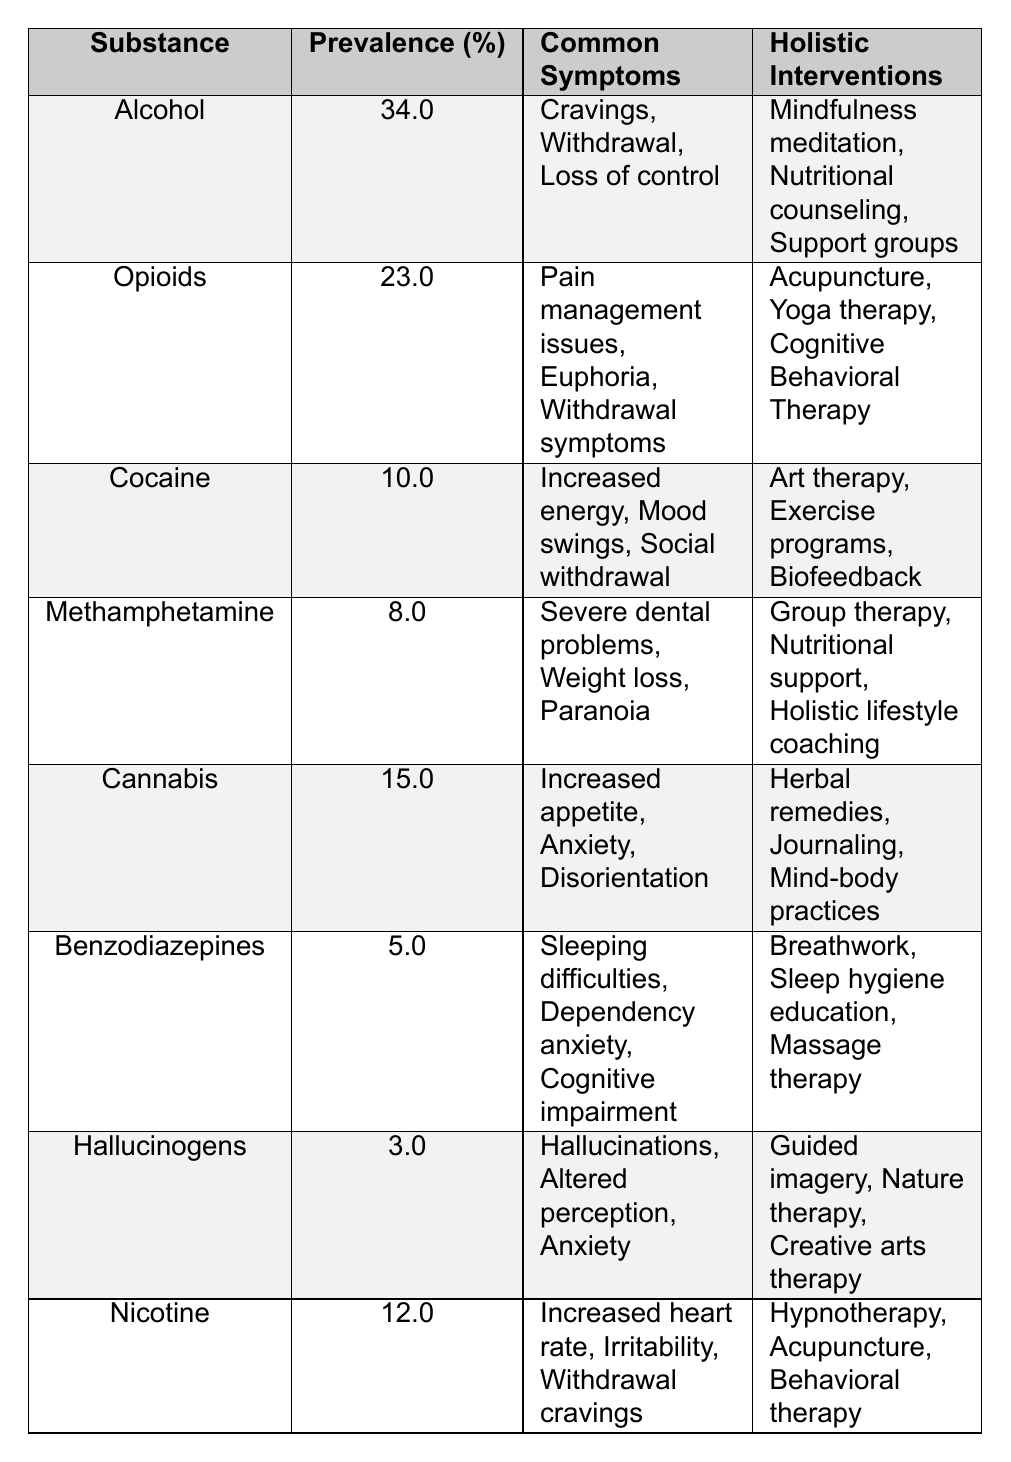What is the prevalence percentage of Alcohol use disorder? The table lists the prevalence percentages for various substances, and for Alcohol, it is specifically noted as 34.0%.
Answer: 34.0% Which substance has the lowest prevalence percentage? By reviewing the prevalence percentages in the table, Hallucinogens are listed with a prevalence of 3.0%, which is the lowest among all substances.
Answer: 3.0% What holistic intervention is suggested for Cannabis use disorder? The table lists the holistic interventions for each substance, and for Cannabis, the suggested interventions include Herbal remedies, Journaling, and Mind-body practices.
Answer: Herbal remedies, Journaling, Mind-body practices How many substances have a prevalence percentage of 10% or lower? The table shows that Hallucinogens (3.0%), Benzodiazepines (5.0%), and Methamphetamine (8.0%) are all at or below 10%. Counting these gives a total of 4 substances: Hallucinogens, Benzodiazepines, Methamphetamine, and Cocaine (10.0%).
Answer: 4 What is the total prevalence percentage of Alcohol and Opioid use disorders combined? The prevalence percentage for Alcohol is 34.0% and for Opioids it is 23.0%. Adding these two gives (34.0 + 23.0) = 57.0%.
Answer: 57.0% Is it true that Nicotine disorder has a higher prevalence than Methamphetamine disorder? Comparing their prevalence percentages in the table, Nicotine is at 12.0%, while Methamphetamine is at 8.0%. Since 12.0% is greater than 8.0%, the statement is true.
Answer: Yes What is the most common symptom associated with Opioid use disorder? The table lists common symptoms for Opioids as Pain management issues, Euphoria, and Withdrawal symptoms; thus one of the main symptoms can be considered Pain management issues.
Answer: Pain management issues Calculate the difference in prevalence percentages between the substance with the highest and lowest prevalence. Alcohol has the highest prevalence at 34.0% and Hallucinogens the lowest at 3.0%. The difference is calculated as (34.0 - 3.0) = 31.0%.
Answer: 31.0% Which holistic intervention is common for both Cannabis and Cocaine use disorders? The holistic interventions for Cannabis include Herbal remedies, Journaling, and Mind-body practices, and for Cocaine they include Art therapy, Exercise programs, and Biofeedback. There are no common interventions listed between Cannabis and Cocaine.
Answer: No common interventions What are the common symptoms for Benzodiazepine use disorder? The common symptoms listed for Benzodiazepines in the table are Sleeping difficulties, Dependency anxiety, and Cognitive impairment.
Answer: Sleeping difficulties, Dependency anxiety, Cognitive impairment 